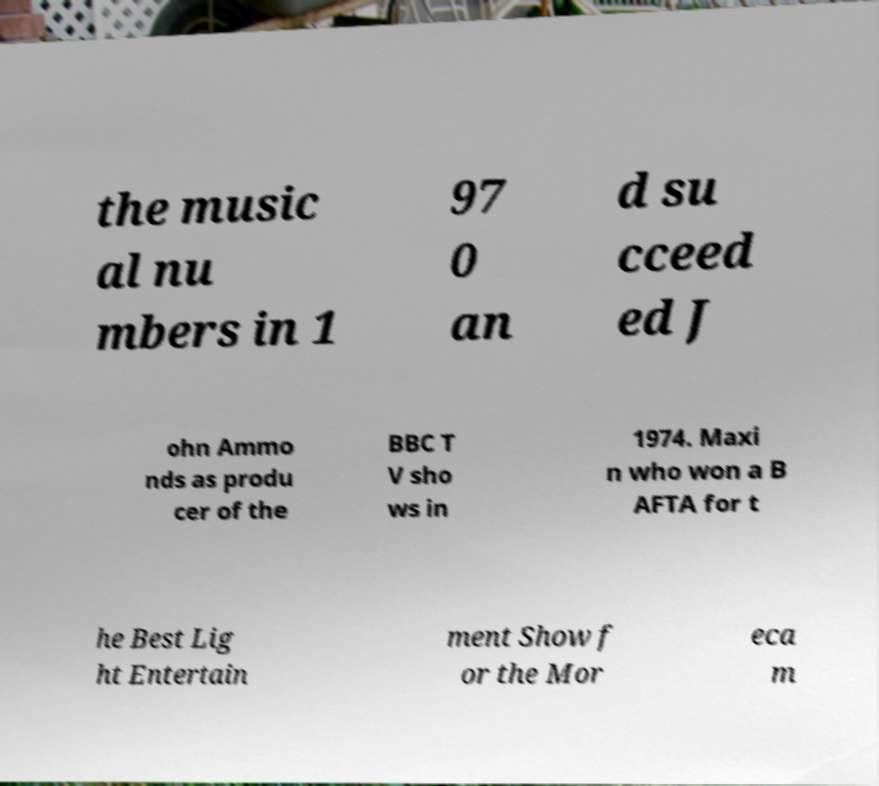I need the written content from this picture converted into text. Can you do that? the music al nu mbers in 1 97 0 an d su cceed ed J ohn Ammo nds as produ cer of the BBC T V sho ws in 1974. Maxi n who won a B AFTA for t he Best Lig ht Entertain ment Show f or the Mor eca m 